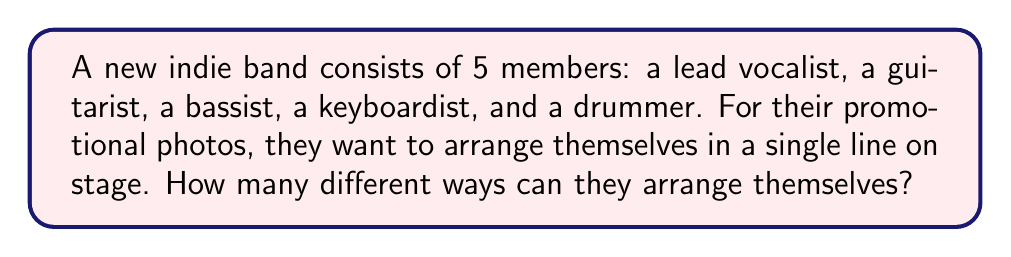Help me with this question. Let's approach this step-by-step:

1) This is a permutation problem. We need to arrange 5 distinct people in a line, where the order matters.

2) For the first position, we have 5 choices (any of the 5 band members can stand first).

3) After placing the first person, we have 4 choices for the second position.

4) For the third position, we'll have 3 choices remaining.

5) For the fourth position, we'll have 2 choices.

6) For the last position, we'll only have 1 choice left (the last remaining person).

7) According to the multiplication principle, we multiply these numbers together:

   $$5 \times 4 \times 3 \times 2 \times 1 = 120$$

8) This is also known as 5 factorial, written as $5!$

Therefore, the number of ways to arrange 5 band members in a line is $5! = 120$.
Answer: $120$ 